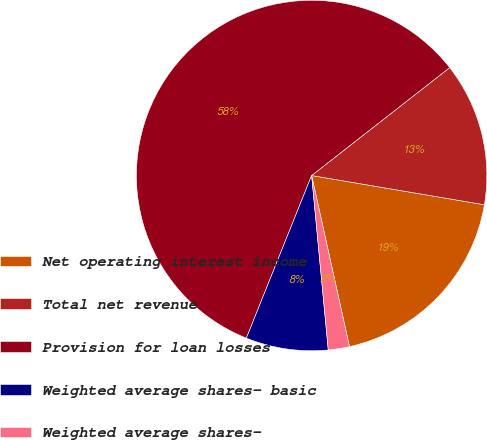Convert chart. <chart><loc_0><loc_0><loc_500><loc_500><pie_chart><fcel>Net operating interest income<fcel>Total net revenue<fcel>Provision for loan losses<fcel>Weighted average shares- basic<fcel>Weighted average shares-<nl><fcel>18.87%<fcel>13.23%<fcel>58.37%<fcel>7.59%<fcel>1.95%<nl></chart> 